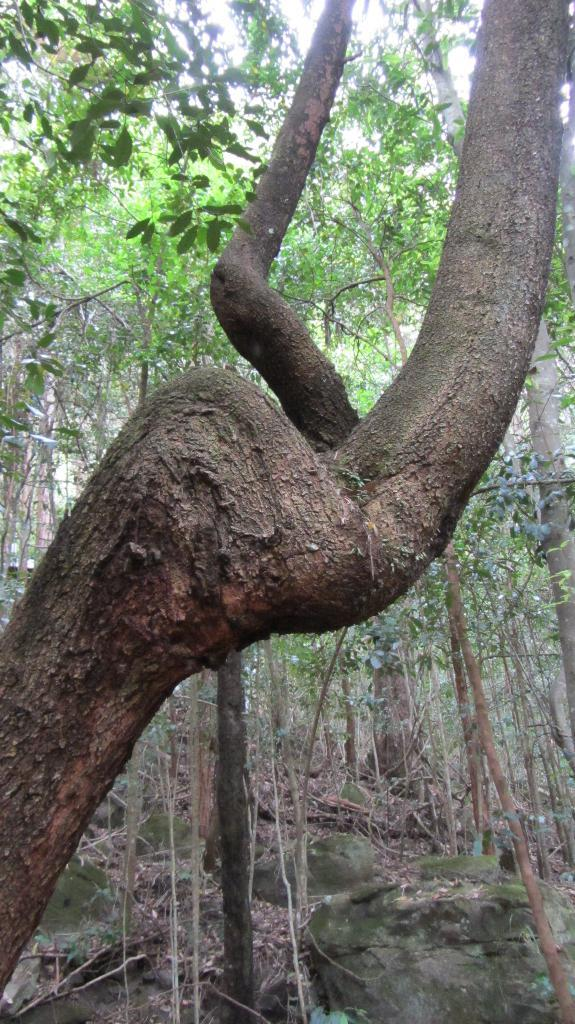What type of natural elements can be seen in the image? There are many trees and rocks in the image. Can you describe the landscape in the image? The landscape in the image is characterized by the presence of trees and rocks. How many balls can be seen in the image? There are no balls present in the image. What type of loaf is being used to create the landscape in the image? There is no loaf present in the image; it is a natural landscape featuring trees and rocks. 